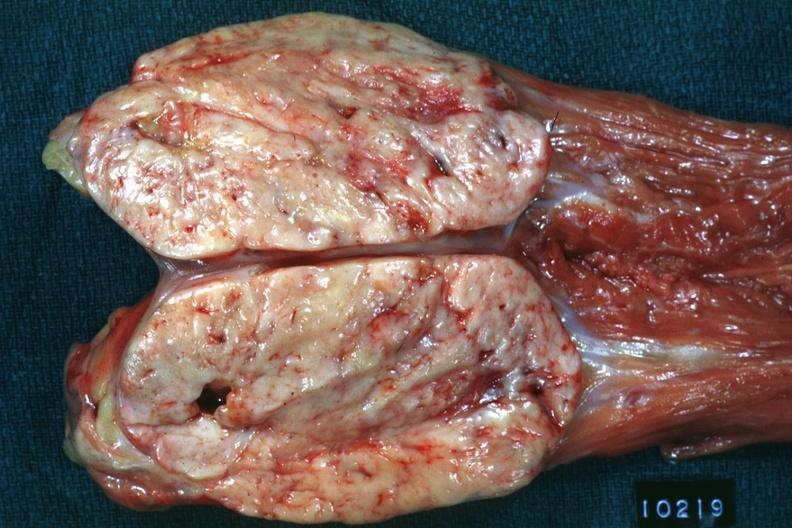does opened muscle psoa natural color large ovoid typical sarcoma?
Answer the question using a single word or phrase. Yes 